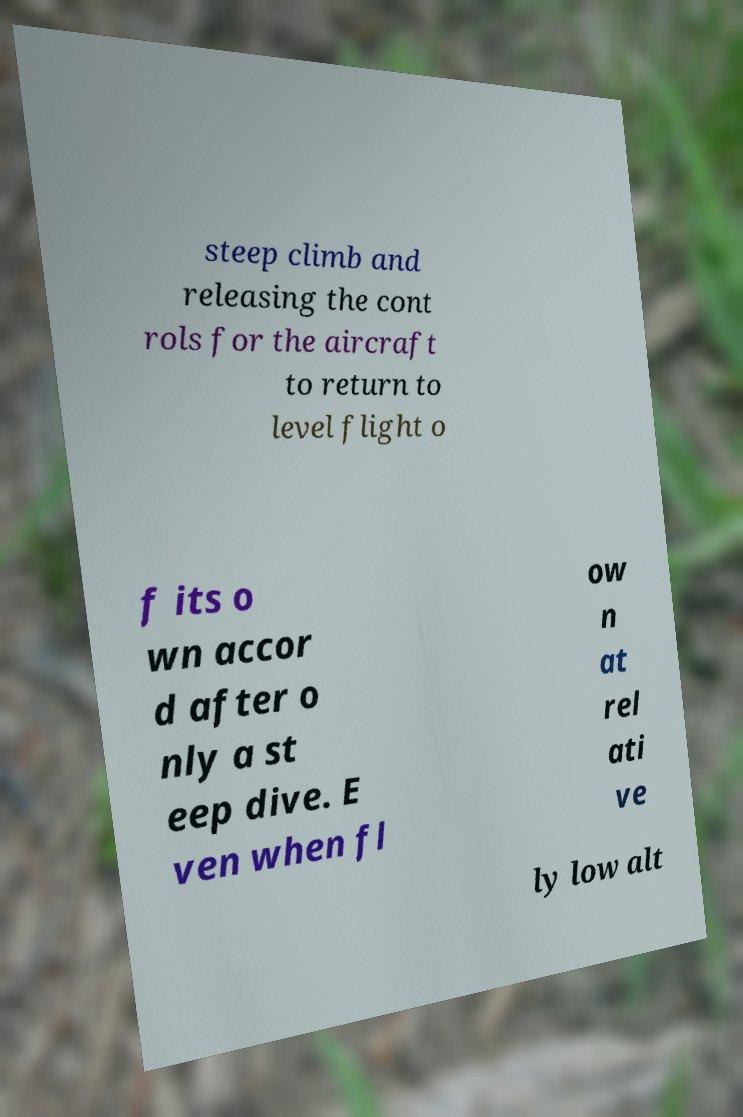There's text embedded in this image that I need extracted. Can you transcribe it verbatim? steep climb and releasing the cont rols for the aircraft to return to level flight o f its o wn accor d after o nly a st eep dive. E ven when fl ow n at rel ati ve ly low alt 